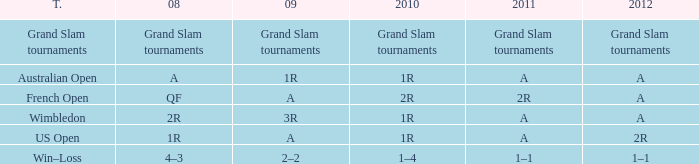Name the 2011 when 2010 is 2r 2R. 